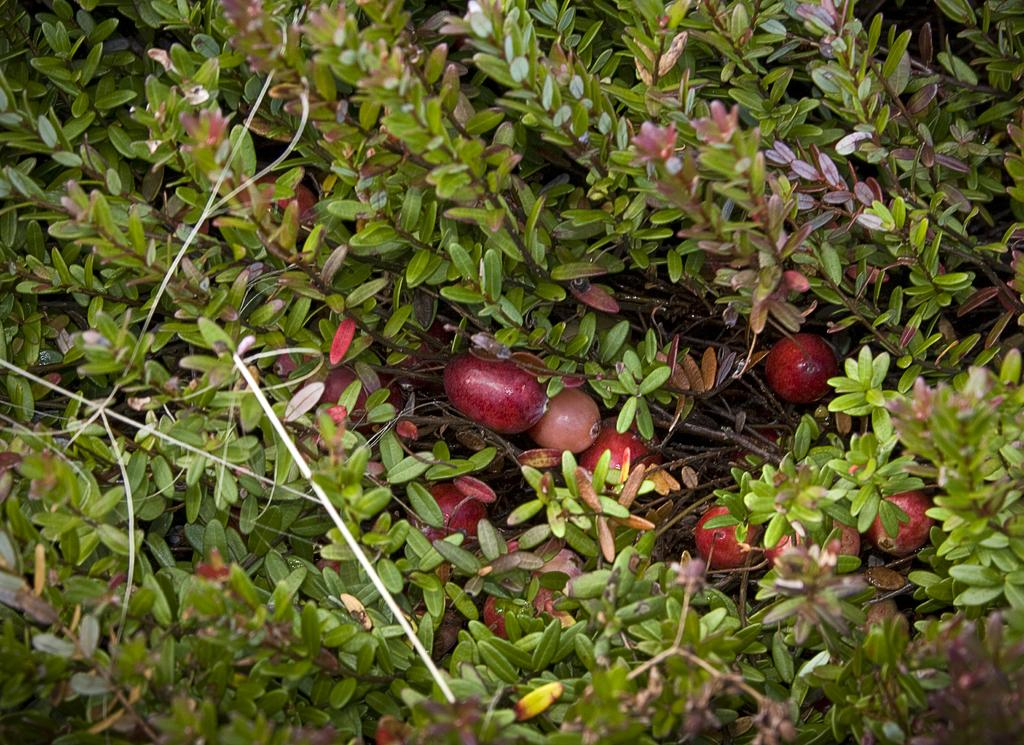What type of objects can be seen in the image? There are many fruits in the image. Where are the fruits located? The fruits are on a plant. What color are the fruits? The fruits are red in color. What color is the plant? The plant is green in color. What suggestion does the plant make to the fruits in the image? There is no suggestion being made by the plant to the fruits in the image, as plants do not communicate in this manner. 